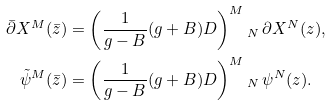Convert formula to latex. <formula><loc_0><loc_0><loc_500><loc_500>\bar { \partial } X ^ { M } ( \bar { z } ) & = \left ( \frac { 1 } { g - B } ( g + B ) D \right ) ^ { M } { _ { N } } \, \partial X ^ { N } ( z ) , \\ \tilde { \psi } ^ { M } ( \bar { z } ) & = \left ( \frac { 1 } { g - B } ( g + B ) D \right ) ^ { M } { _ { N } } \, \psi ^ { N } ( z ) .</formula> 